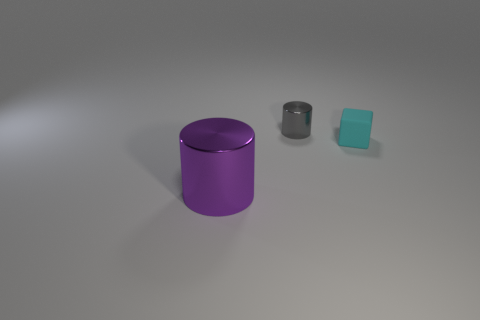What is the color of the large cylinder? purple 